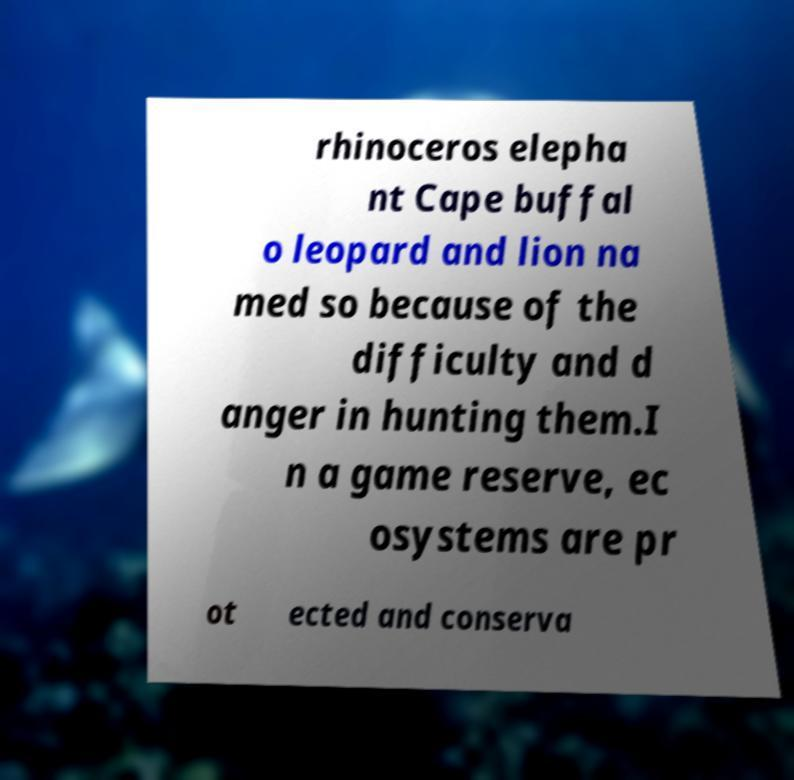Can you accurately transcribe the text from the provided image for me? rhinoceros elepha nt Cape buffal o leopard and lion na med so because of the difficulty and d anger in hunting them.I n a game reserve, ec osystems are pr ot ected and conserva 